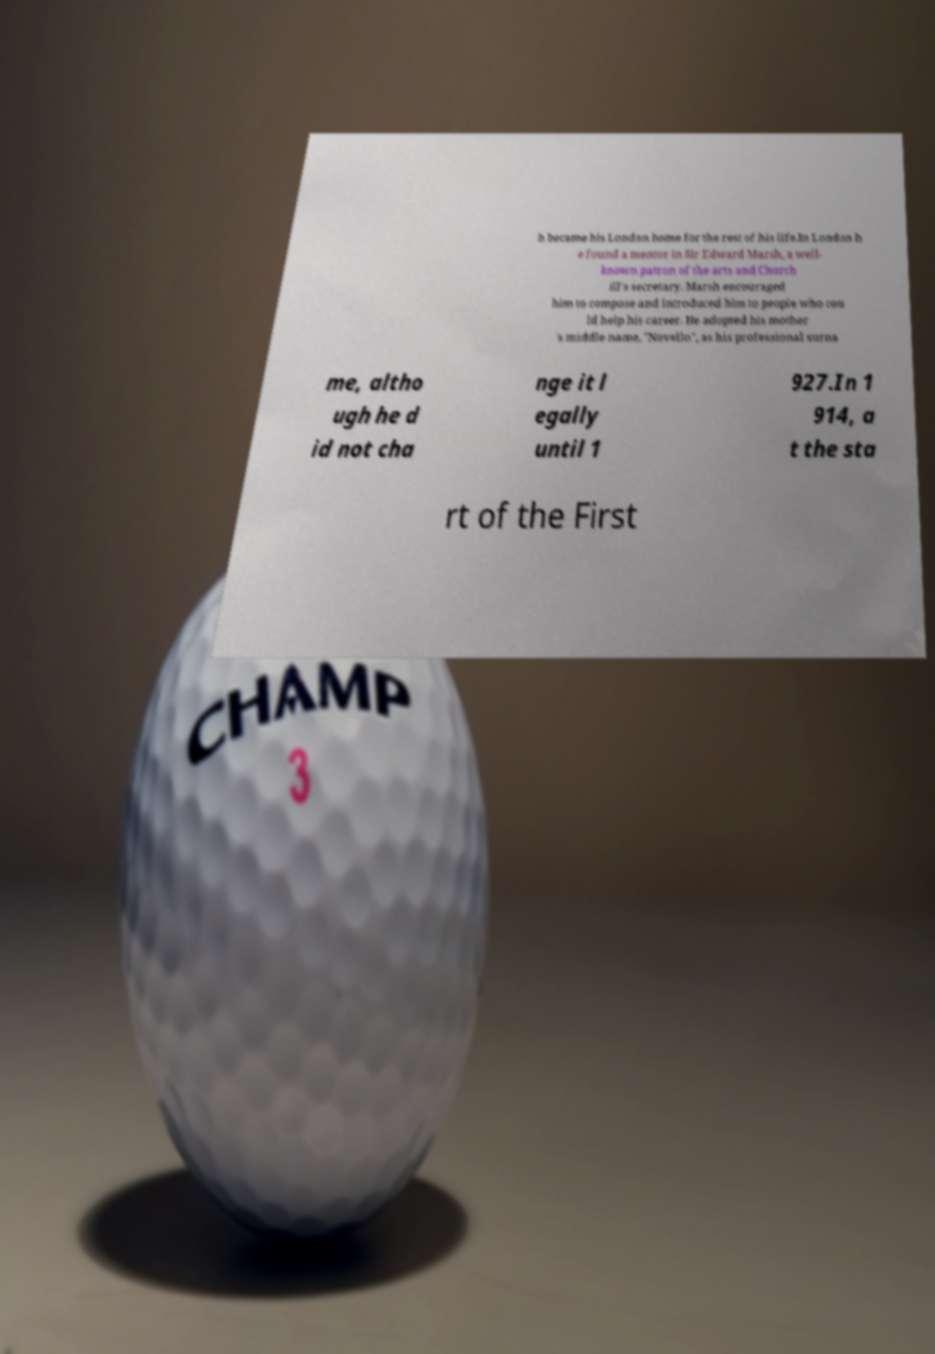Could you assist in decoding the text presented in this image and type it out clearly? h became his London home for the rest of his life.In London h e found a mentor in Sir Edward Marsh, a well- known patron of the arts and Church ill's secretary. Marsh encouraged him to compose and introduced him to people who cou ld help his career. He adopted his mother 's middle name, "Novello", as his professional surna me, altho ugh he d id not cha nge it l egally until 1 927.In 1 914, a t the sta rt of the First 